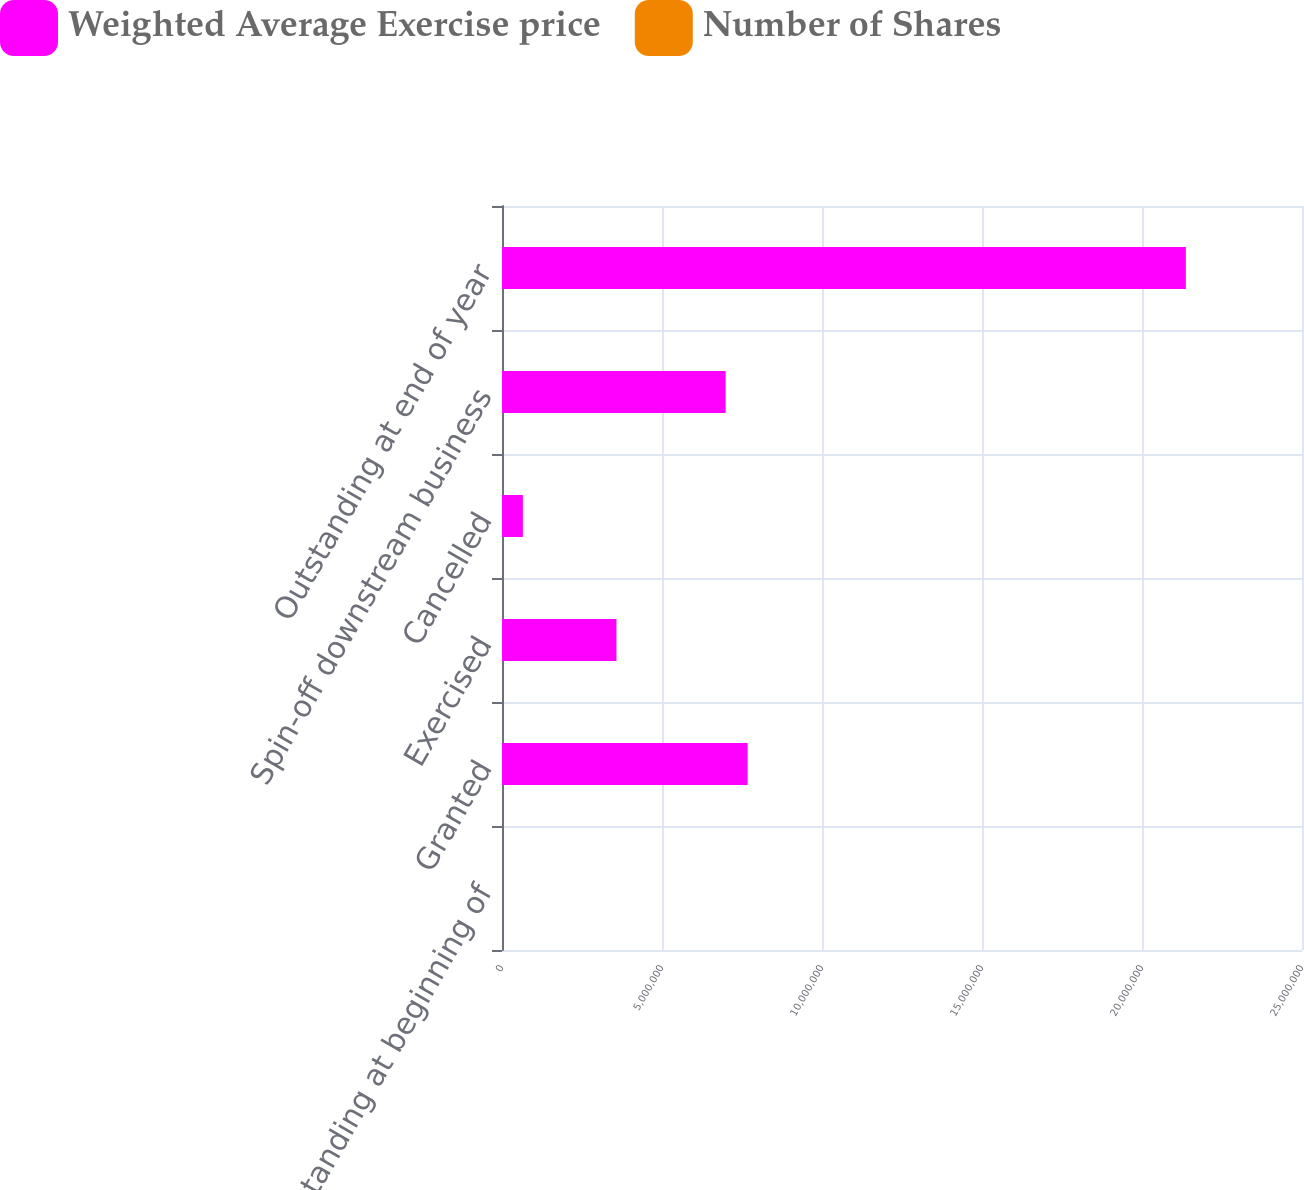<chart> <loc_0><loc_0><loc_500><loc_500><stacked_bar_chart><ecel><fcel>Outstanding at beginning of<fcel>Granted<fcel>Exercised<fcel>Cancelled<fcel>Spin-off downstream business<fcel>Outstanding at end of year<nl><fcel>Weighted Average Exercise price<fcel>32.3<fcel>7.67654e+06<fcel>3.57637e+06<fcel>652607<fcel>6.98911e+06<fcel>2.13707e+07<nl><fcel>Number of Shares<fcel>24.85<fcel>32.3<fcel>15.12<fcel>25.88<fcel>30.94<fcel>24.41<nl></chart> 